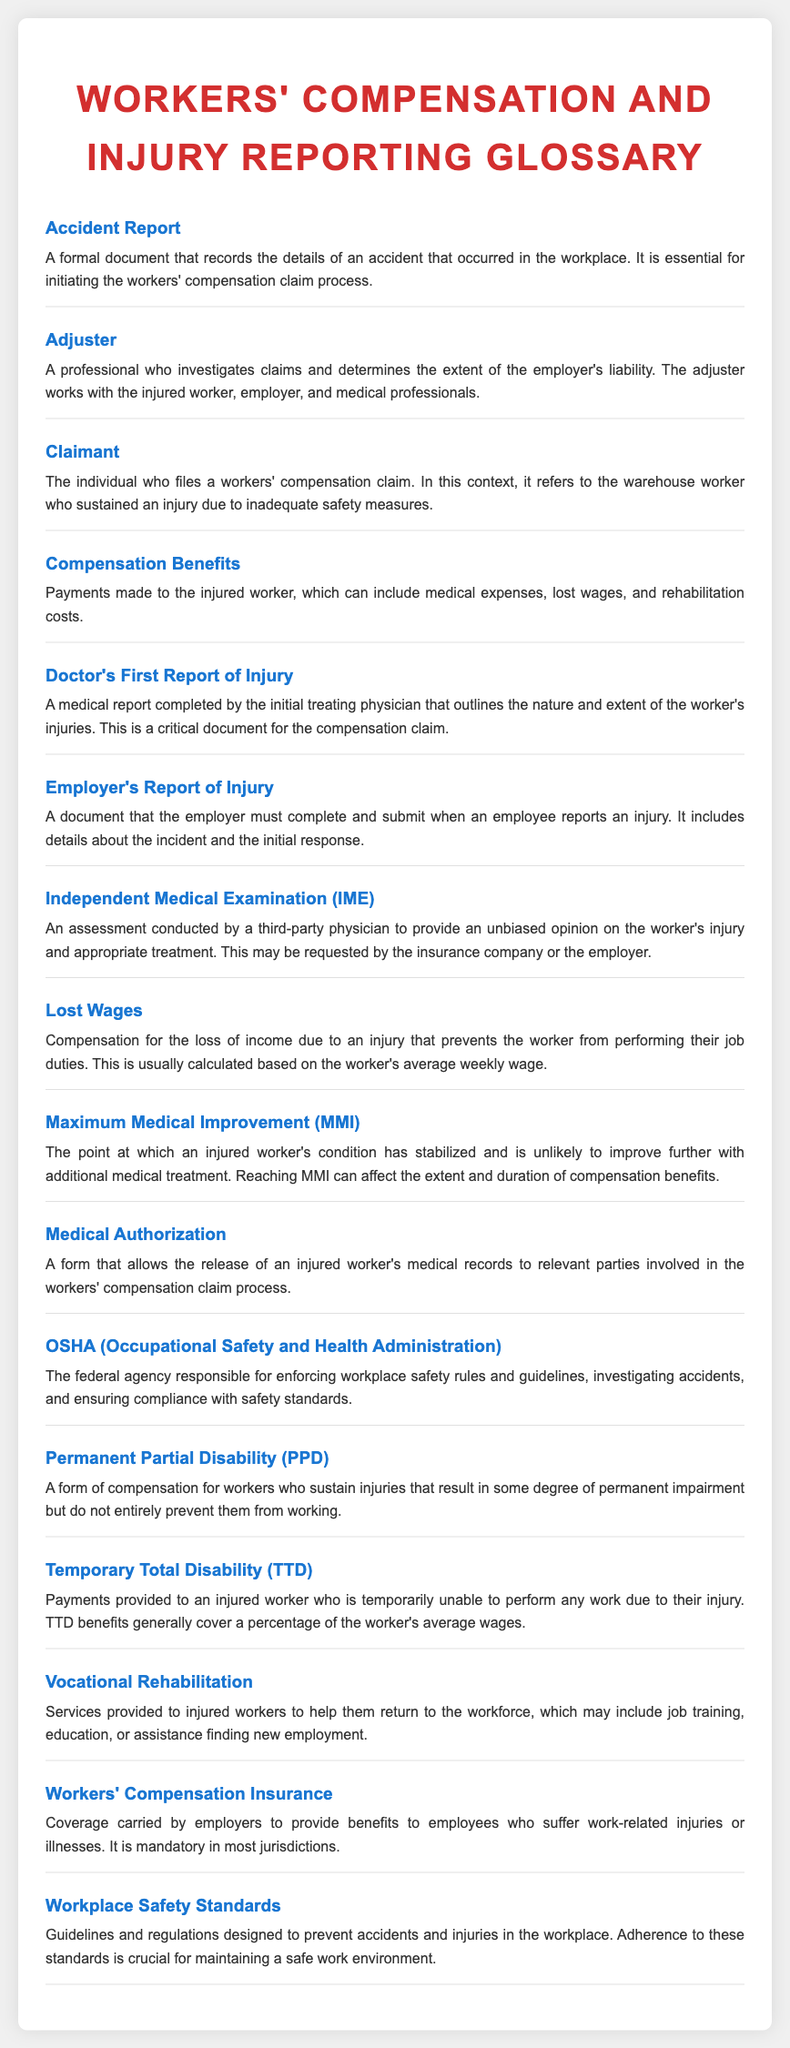What is an Accident Report? An Accident Report is a formal document that records the details of an accident that occurred in the workplace.
Answer: A formal document What does an Adjuster do? An Adjuster is a professional who investigates claims and determines the extent of the employer's liability.
Answer: Investigates claims Who is the Claimant in the context of workers' compensation? The Claimant refers to the individual who files a workers' compensation claim, specifically the injured warehouse worker.
Answer: Injured warehouse worker What are Compensation Benefits? Compensation Benefits are payments made to the injured worker, which can include medical expenses, lost wages, and rehabilitation costs.
Answer: Payments made to the injured worker What is the purpose of a Doctor's First Report of Injury? A Doctor's First Report of Injury outlines the nature and extent of the worker's injuries and is critical for the compensation claim.
Answer: Critical document What does MMI stand for? MMI stands for Maximum Medical Improvement, which indicates the point at which an injured worker's condition has stabilized.
Answer: Maximum Medical Improvement What kind of injuries does Permanent Partial Disability (PPD) refer to? PPD refers to injuries that result in some degree of permanent impairment but do not entirely prevent workers from working.
Answer: Some degree of permanent impairment What are Temporary Total Disability (TTD) benefits? TTD benefits are payments provided to an injured worker who is temporarily unable to perform any work due to their injury.
Answer: Payments provided to an injured worker What role does OSHA play? OSHA is the federal agency responsible for enforcing workplace safety rules and ensuring compliance with safety standards.
Answer: Enforcing workplace safety rules What is the aim of Vocational Rehabilitation? Vocational Rehabilitation aims to provide services to injured workers to help them return to the workforce.
Answer: Help them return to the workforce 